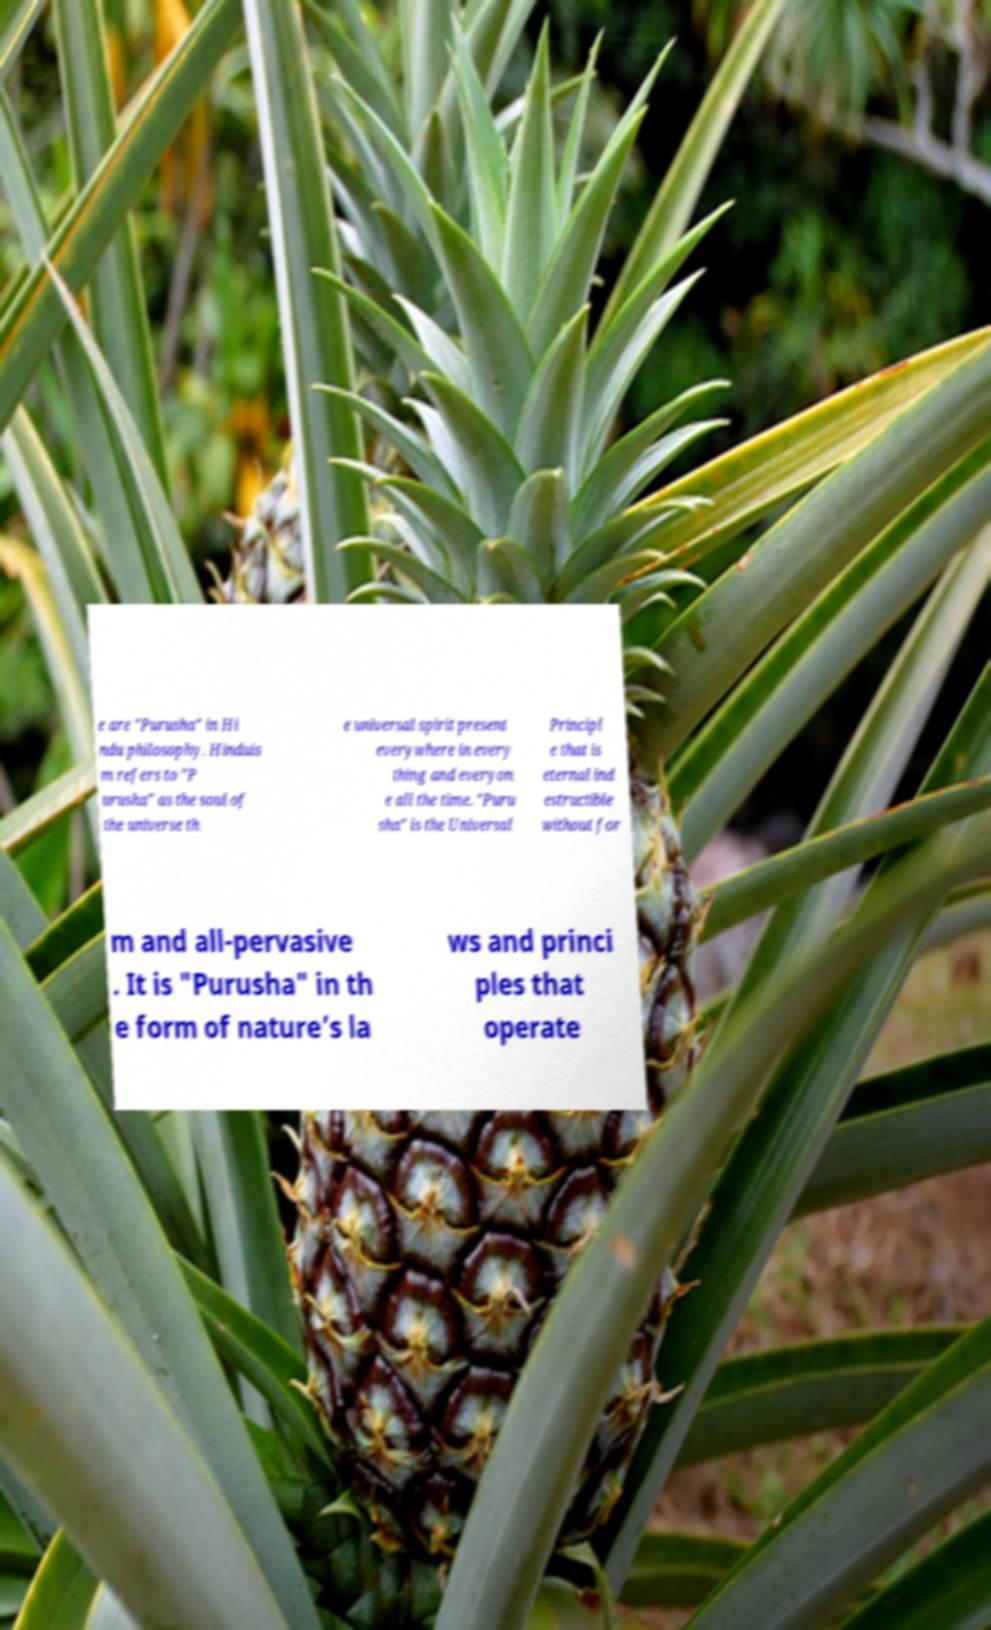Could you extract and type out the text from this image? e are "Purusha" in Hi ndu philosophy. Hinduis m refers to "P urusha" as the soul of the universe th e universal spirit present everywhere in every thing and everyon e all the time. "Puru sha" is the Universal Principl e that is eternal ind estructible without for m and all-pervasive . It is "Purusha" in th e form of nature’s la ws and princi ples that operate 